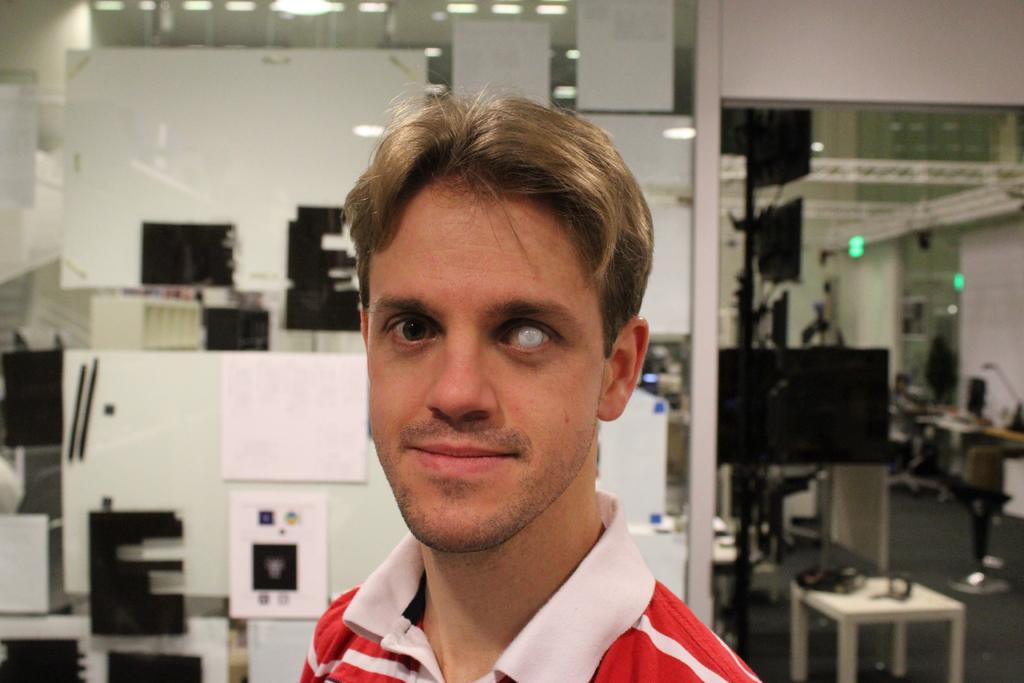Who or what is the main subject in the image? There is a person in the image. What can be seen in the background of the image? There are machines, a stool, and lights in the background of the image. What type of cabbage is being used to power the machines in the image? There is no cabbage present in the image, and the machines are not powered by cabbage. 